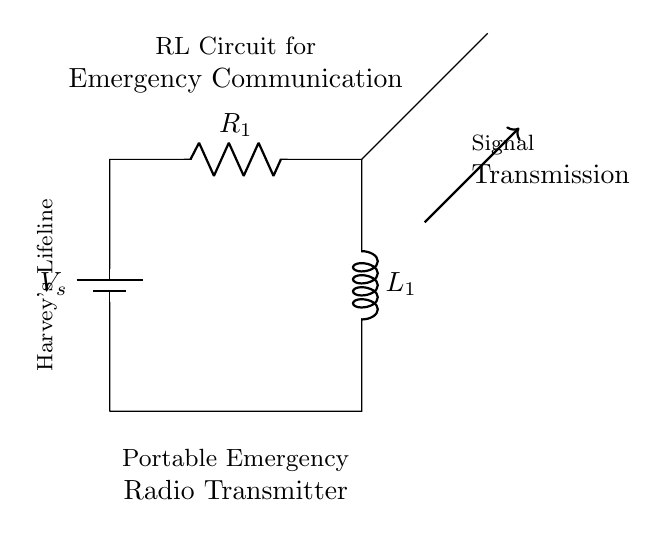What is the source voltage in this circuit? The source voltage is represented by the battery symbol labeled V_s in the circuit diagram. This indicates a voltage source supplying power to the circuit.
Answer: V_s What is the resistance value of R1? In the circuit diagram, R1 is labeled as a resistor, but specific resistance values are not provided. It represents a variable value that is not specified here.
Answer: Not specified What does L1 indicate in the circuit? L1 is marked as an inductor on the circuit diagram. It indicates the presence of inductive reactance, which affects the circuit’s behavior in relation to alternating current.
Answer: Inductor How many components are connected in series in this circuit? The battery, resistor, and inductor are all connected in series, forming a single path for current flow. The number of components is three.
Answer: Three What type of circuit is represented here? This circuit features a resistor and an inductor, making it an RL circuit designed specifically for certain frequency characteristics including filtering and signal propagation.
Answer: RL circuit What is the purpose of the antenna in this circuit? The antenna is used for transmitting signals generated by the RL circuit. It converts electrical signals into electromagnetic waves that can be received by radio devices.
Answer: Signal transmission What role does the resistor play in this RL circuit? The resistor is essential for limiting the current flow and managing voltage within the circuit, which also stabilizes the overall circuit performance when combined with the inductor.
Answer: Current limiting 